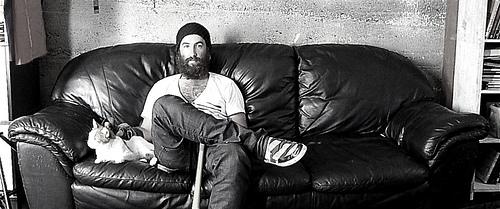Does he have a beard?
Write a very short answer. Yes. Which leg is crossed?
Write a very short answer. Right. What is laying on the sofa next to the man?
Keep it brief. Cat. 